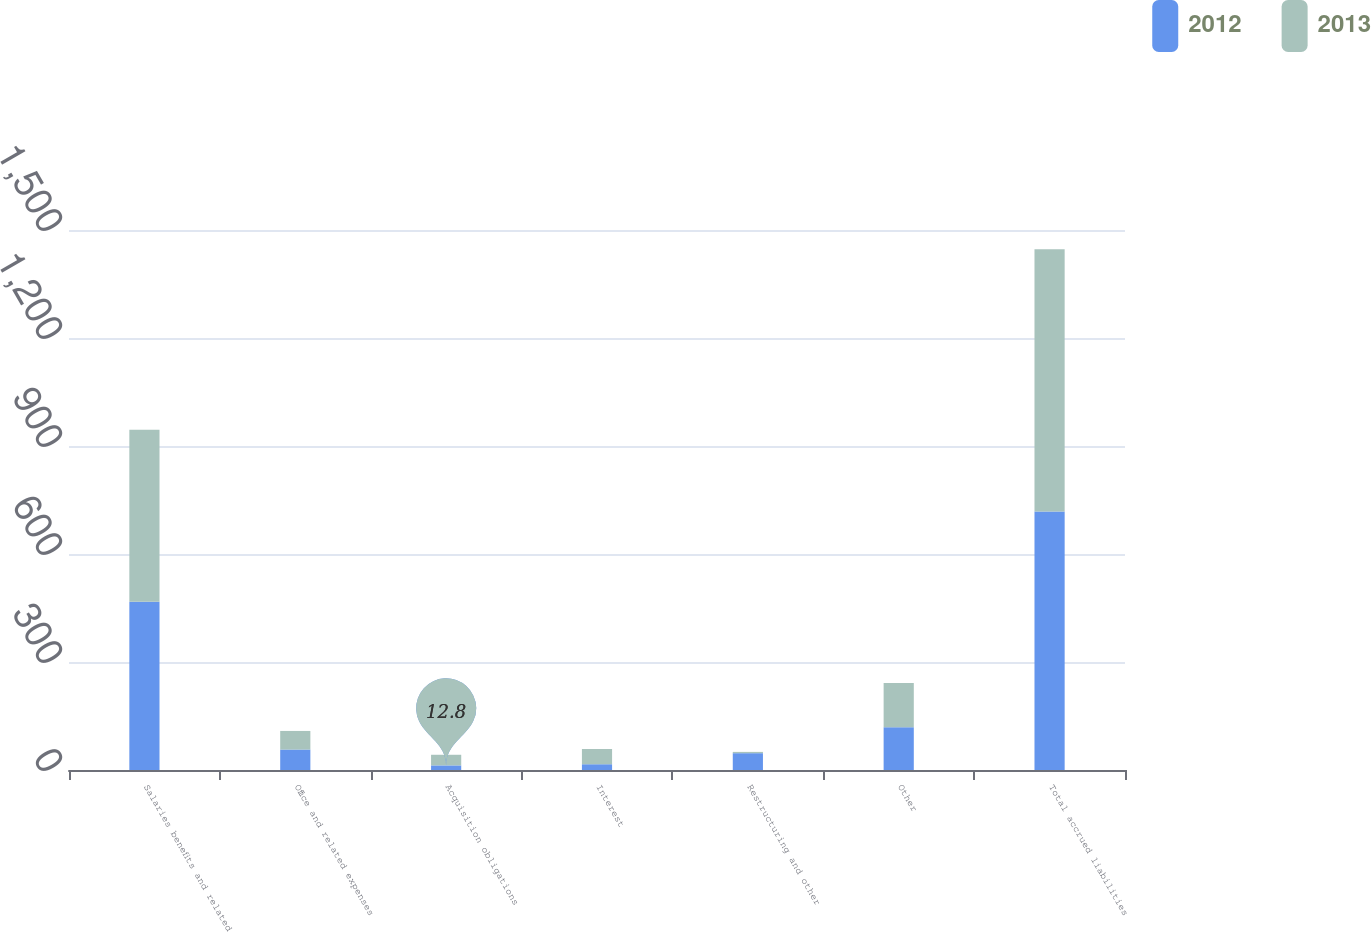Convert chart to OTSL. <chart><loc_0><loc_0><loc_500><loc_500><stacked_bar_chart><ecel><fcel>Salaries benefits and related<fcel>Office and related expenses<fcel>Acquisition obligations<fcel>Interest<fcel>Restructuring and other<fcel>Other<fcel>Total accrued liabilities<nl><fcel>2012<fcel>467.2<fcel>56.9<fcel>12.8<fcel>16<fcel>46.7<fcel>118.8<fcel>718.4<nl><fcel>2013<fcel>478.2<fcel>51.6<fcel>29.5<fcel>42.4<fcel>3.6<fcel>122.9<fcel>728.2<nl></chart> 